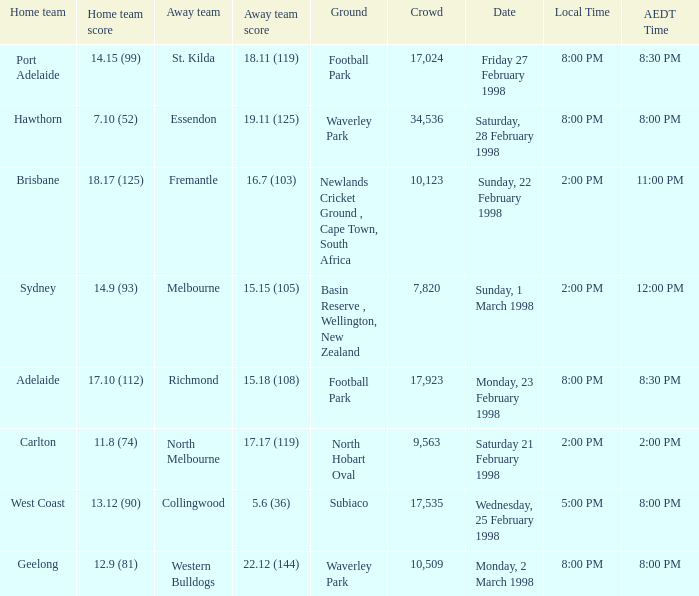Name the Away team which has a Ground of waverley park, and a Home team of hawthorn? Essendon. 